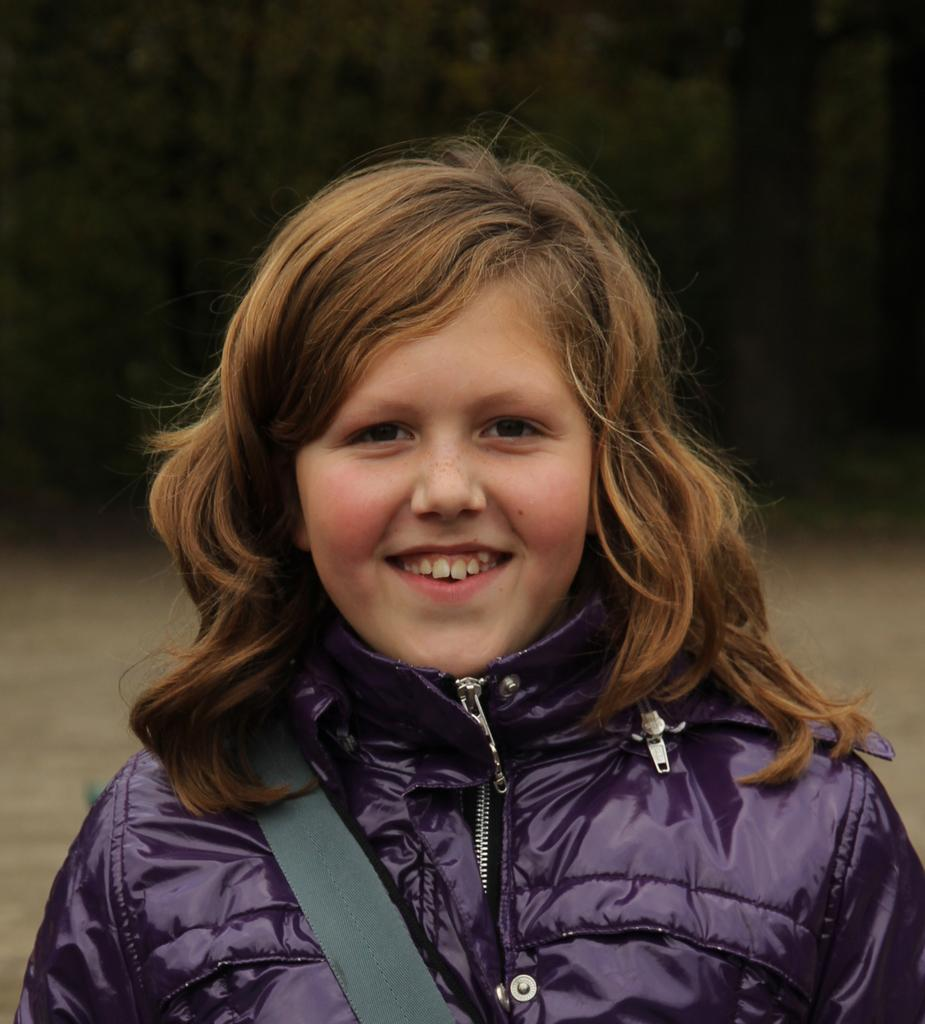Who is the main subject in the image? There is a girl in the image. What is the girl wearing in the image? The girl is wearing a jacket. What is the girl's facial expression in the image? The girl is smiling. What accessory is visible in the image? There is a belt visible in the image. How would you describe the background of the image? The background of the image is blurred. What type of oatmeal is the girl eating in the image? There is no oatmeal present in the image; the girl is not eating anything. 